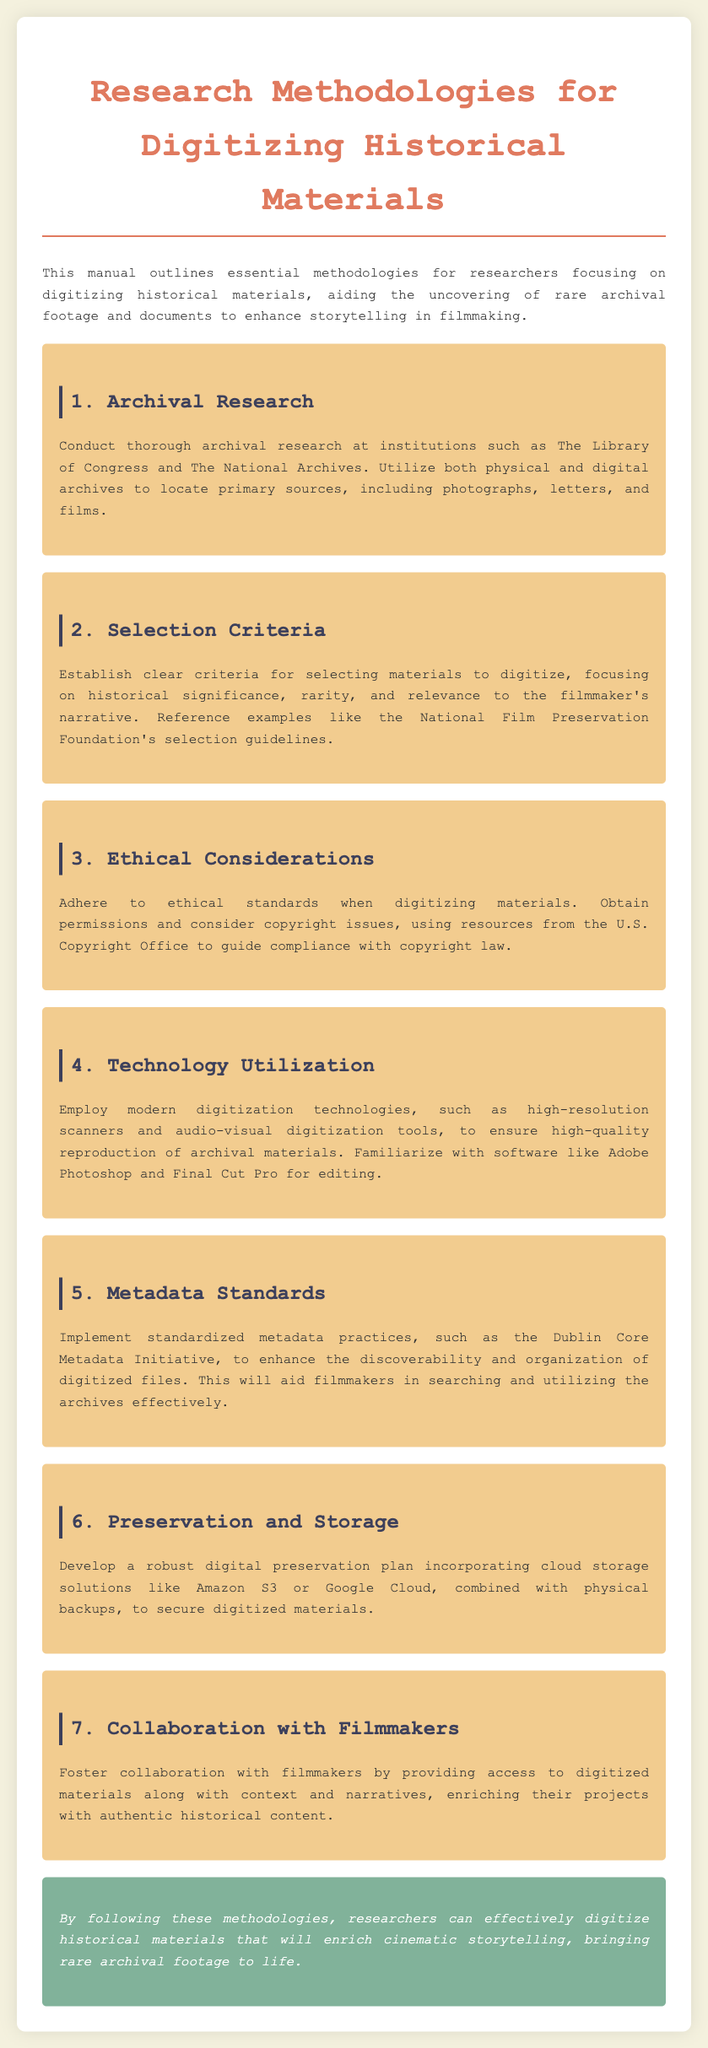What is the title of the manual? The title of the manual is stated in the heading of the document.
Answer: Research Methodologies for Digitizing Historical Materials Where should archival research be conducted? The document mentions specific institutions where archival research is encouraged.
Answer: The Library of Congress and The National Archives What technology is recommended for digitization? The manual lists technologies that should be used for digitizing historical materials.
Answer: High-resolution scanners and audio-visual digitization tools Which standard is recommended for metadata practices? The appropriate metadata standard is identified in the document.
Answer: Dublin Core Metadata Initiative What is an important aspect of selection criteria? The document specifies historical significance as part of the criteria.
Answer: Historical significance Why is collaboration with filmmakers emphasized? The reason for this is related to enhancing projects with contextual information.
Answer: Enriching their projects with authentic historical content What should be included in a digital preservation plan? The document indicates the components of a digital preservation strategy.
Answer: Cloud storage solutions and physical backups What is the background color of the manual's body? The background color of the manual is described in the styling section of the document.
Answer: #f4f1de How should permissions be handled when digitizing materials? The document advises on the necessary steps for copyright compliance.
Answer: Obtain permissions 